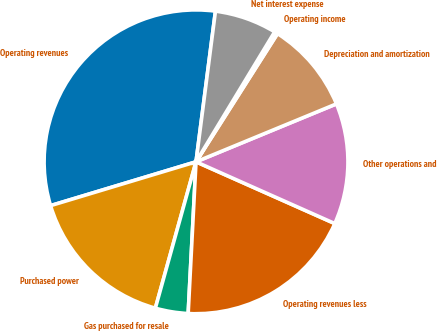Convert chart to OTSL. <chart><loc_0><loc_0><loc_500><loc_500><pie_chart><fcel>Operating revenues<fcel>Purchased power<fcel>Gas purchased for resale<fcel>Operating revenues less<fcel>Other operations and<fcel>Depreciation and amortization<fcel>Operating income<fcel>Net interest expense<nl><fcel>31.7%<fcel>16.03%<fcel>3.49%<fcel>19.16%<fcel>12.89%<fcel>9.76%<fcel>0.35%<fcel>6.62%<nl></chart> 